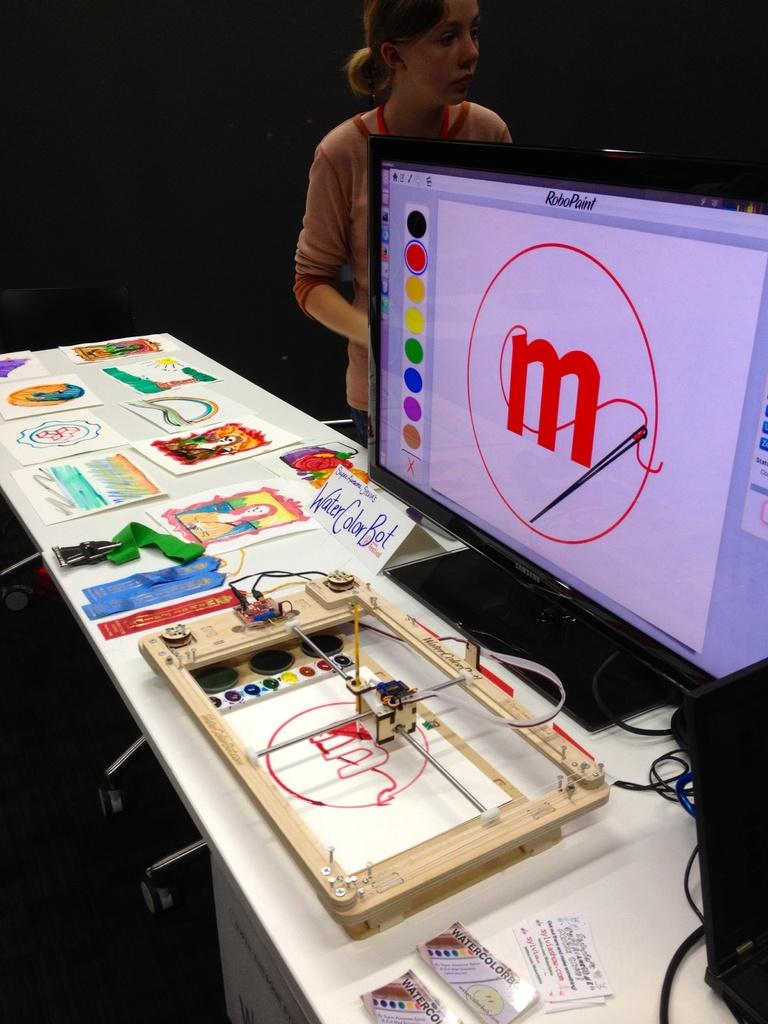What is the main piece of furniture in the image? There is a table in the image. What electronic device is on the table? There is a monitor on the table. What type of items are on the table besides the monitor? There are cards, cables, and other objects on the table. Can you describe the woman in the background of the image? The woman is in the background of the image, but no specific details about her appearance are provided. What is the lighting condition in the image? The background of the image is dark. How many ladybugs can be seen crawling on the roof in the image? There are no ladybugs or roof present in the image. Is the woman in the background of the image holding an umbrella during the rainstorm? There is no rainstorm depicted in the image, and the woman's actions are not described. 